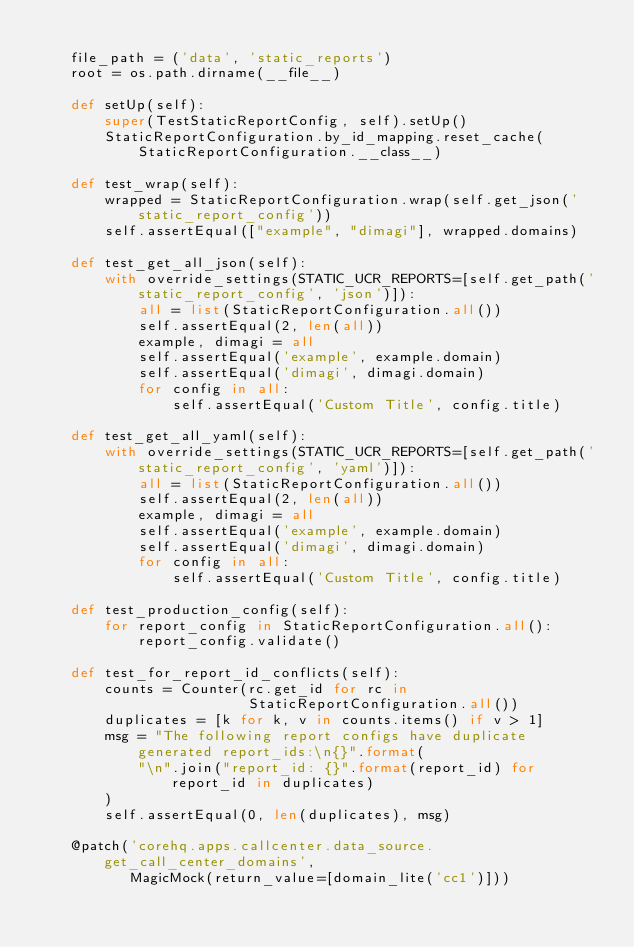<code> <loc_0><loc_0><loc_500><loc_500><_Python_>
    file_path = ('data', 'static_reports')
    root = os.path.dirname(__file__)

    def setUp(self):
        super(TestStaticReportConfig, self).setUp()
        StaticReportConfiguration.by_id_mapping.reset_cache(StaticReportConfiguration.__class__)

    def test_wrap(self):
        wrapped = StaticReportConfiguration.wrap(self.get_json('static_report_config'))
        self.assertEqual(["example", "dimagi"], wrapped.domains)

    def test_get_all_json(self):
        with override_settings(STATIC_UCR_REPORTS=[self.get_path('static_report_config', 'json')]):
            all = list(StaticReportConfiguration.all())
            self.assertEqual(2, len(all))
            example, dimagi = all
            self.assertEqual('example', example.domain)
            self.assertEqual('dimagi', dimagi.domain)
            for config in all:
                self.assertEqual('Custom Title', config.title)

    def test_get_all_yaml(self):
        with override_settings(STATIC_UCR_REPORTS=[self.get_path('static_report_config', 'yaml')]):
            all = list(StaticReportConfiguration.all())
            self.assertEqual(2, len(all))
            example, dimagi = all
            self.assertEqual('example', example.domain)
            self.assertEqual('dimagi', dimagi.domain)
            for config in all:
                self.assertEqual('Custom Title', config.title)

    def test_production_config(self):
        for report_config in StaticReportConfiguration.all():
            report_config.validate()

    def test_for_report_id_conflicts(self):
        counts = Counter(rc.get_id for rc in
                         StaticReportConfiguration.all())
        duplicates = [k for k, v in counts.items() if v > 1]
        msg = "The following report configs have duplicate generated report_ids:\n{}".format(
            "\n".join("report_id: {}".format(report_id) for report_id in duplicates)
        )
        self.assertEqual(0, len(duplicates), msg)

    @patch('corehq.apps.callcenter.data_source.get_call_center_domains',
           MagicMock(return_value=[domain_lite('cc1')]))</code> 